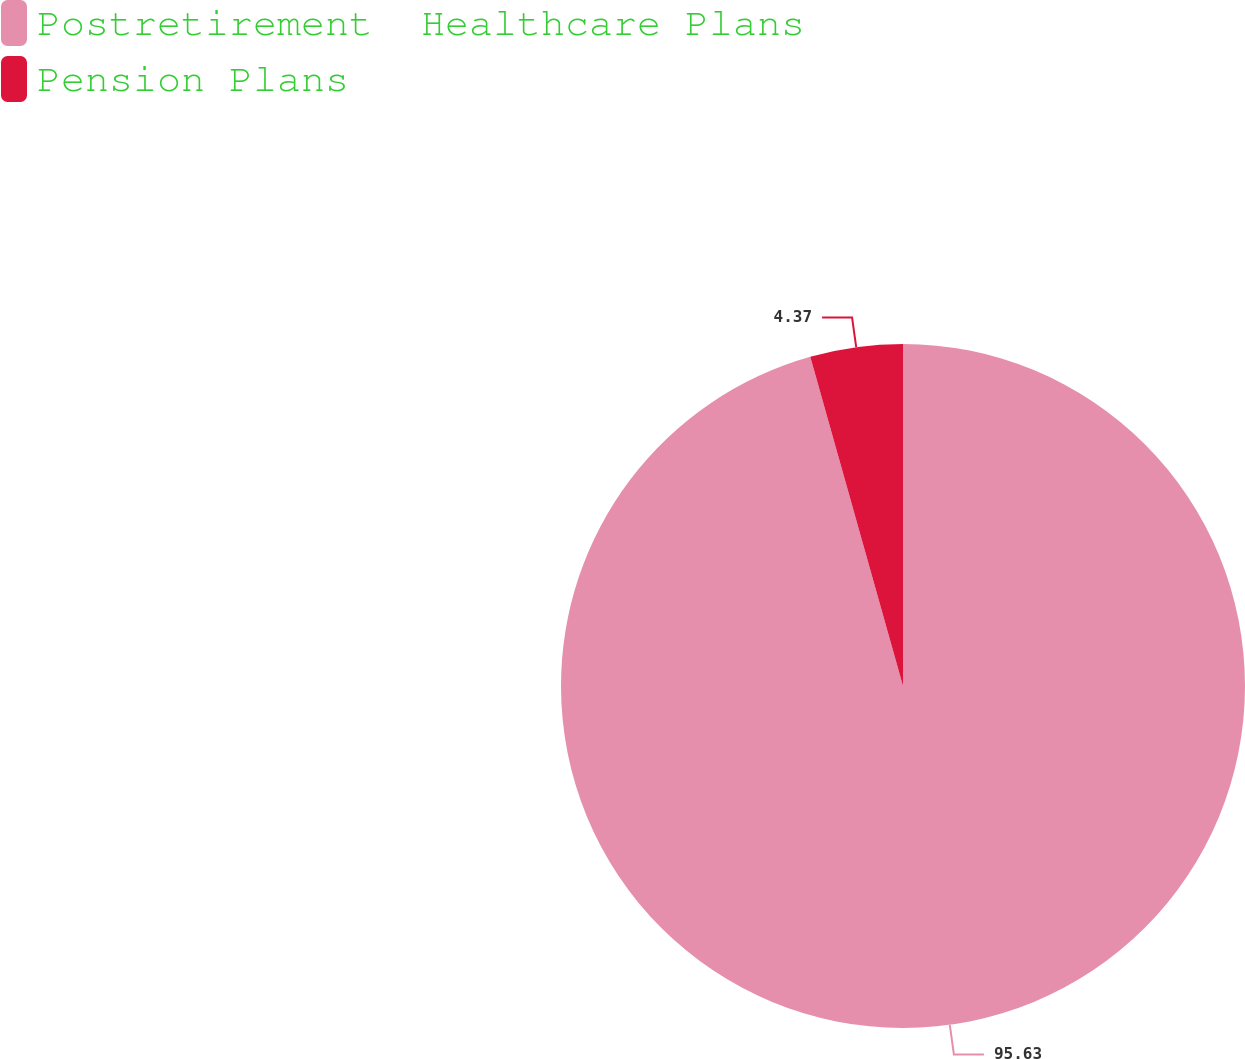Convert chart. <chart><loc_0><loc_0><loc_500><loc_500><pie_chart><fcel>Postretirement  Healthcare Plans<fcel>Pension Plans<nl><fcel>95.63%<fcel>4.37%<nl></chart> 